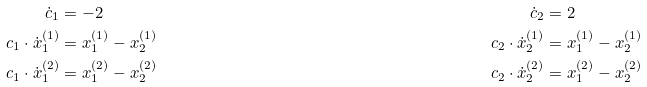Convert formula to latex. <formula><loc_0><loc_0><loc_500><loc_500>\dot { c } _ { 1 } & = - 2 & \dot { c } _ { 2 } & = 2 \\ c _ { 1 } \cdot \dot { x } _ { 1 } ^ { ( 1 ) } & = x _ { 1 } ^ { ( 1 ) } - x _ { 2 } ^ { ( 1 ) } & c _ { 2 } \cdot \dot { x } _ { 2 } ^ { ( 1 ) } & = x _ { 1 } ^ { ( 1 ) } - x _ { 2 } ^ { ( 1 ) } \\ c _ { 1 } \cdot \dot { x } _ { 1 } ^ { ( 2 ) } & = x _ { 1 } ^ { ( 2 ) } - x _ { 2 } ^ { ( 2 ) } & c _ { 2 } \cdot \dot { x } _ { 2 } ^ { ( 2 ) } & = x _ { 1 } ^ { ( 2 ) } - x _ { 2 } ^ { ( 2 ) }</formula> 